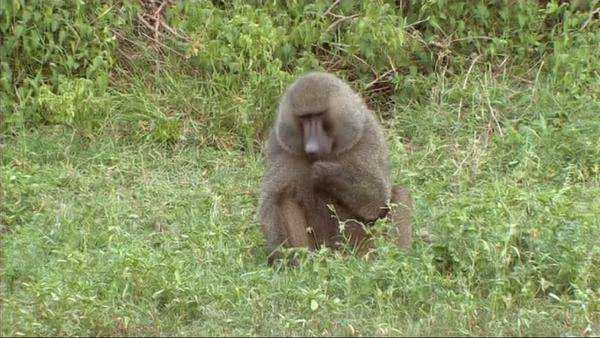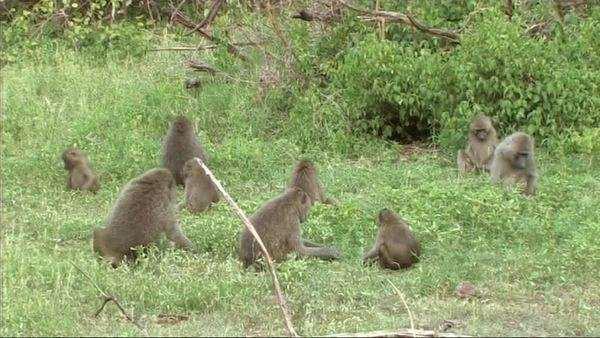The first image is the image on the left, the second image is the image on the right. Considering the images on both sides, is "there are no more than 4 baboons in the pair of images" valid? Answer yes or no. No. 